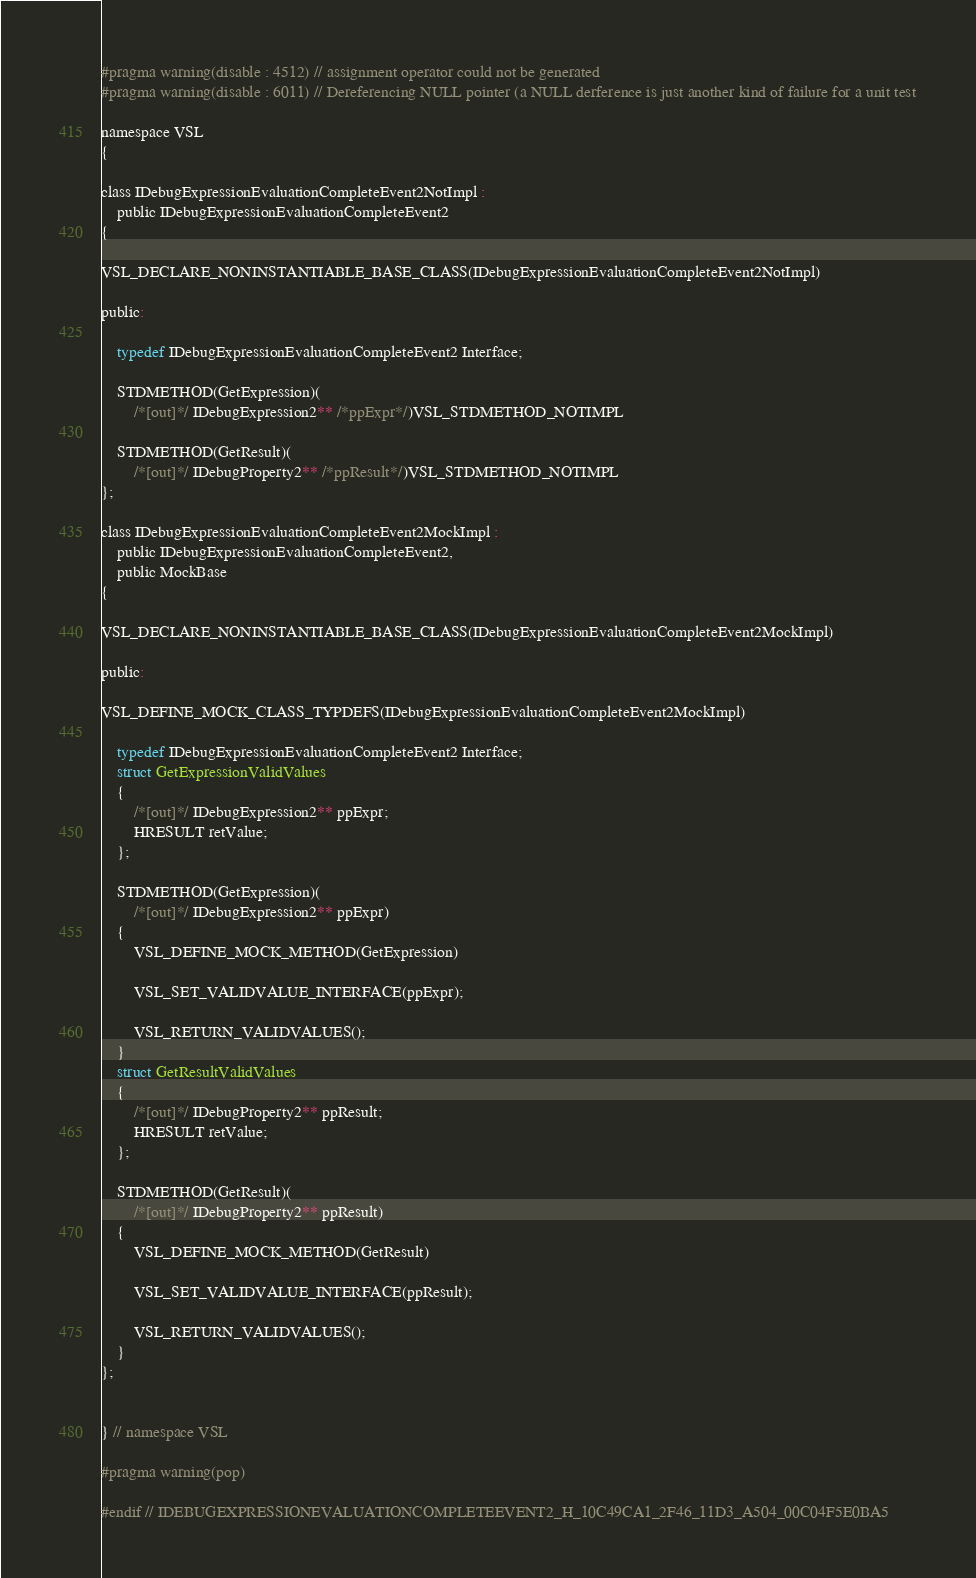<code> <loc_0><loc_0><loc_500><loc_500><_C_>#pragma warning(disable : 4512) // assignment operator could not be generated
#pragma warning(disable : 6011) // Dereferencing NULL pointer (a NULL derference is just another kind of failure for a unit test

namespace VSL
{

class IDebugExpressionEvaluationCompleteEvent2NotImpl :
	public IDebugExpressionEvaluationCompleteEvent2
{

VSL_DECLARE_NONINSTANTIABLE_BASE_CLASS(IDebugExpressionEvaluationCompleteEvent2NotImpl)

public:

	typedef IDebugExpressionEvaluationCompleteEvent2 Interface;

	STDMETHOD(GetExpression)(
		/*[out]*/ IDebugExpression2** /*ppExpr*/)VSL_STDMETHOD_NOTIMPL

	STDMETHOD(GetResult)(
		/*[out]*/ IDebugProperty2** /*ppResult*/)VSL_STDMETHOD_NOTIMPL
};

class IDebugExpressionEvaluationCompleteEvent2MockImpl :
	public IDebugExpressionEvaluationCompleteEvent2,
	public MockBase
{

VSL_DECLARE_NONINSTANTIABLE_BASE_CLASS(IDebugExpressionEvaluationCompleteEvent2MockImpl)

public:

VSL_DEFINE_MOCK_CLASS_TYPDEFS(IDebugExpressionEvaluationCompleteEvent2MockImpl)

	typedef IDebugExpressionEvaluationCompleteEvent2 Interface;
	struct GetExpressionValidValues
	{
		/*[out]*/ IDebugExpression2** ppExpr;
		HRESULT retValue;
	};

	STDMETHOD(GetExpression)(
		/*[out]*/ IDebugExpression2** ppExpr)
	{
		VSL_DEFINE_MOCK_METHOD(GetExpression)

		VSL_SET_VALIDVALUE_INTERFACE(ppExpr);

		VSL_RETURN_VALIDVALUES();
	}
	struct GetResultValidValues
	{
		/*[out]*/ IDebugProperty2** ppResult;
		HRESULT retValue;
	};

	STDMETHOD(GetResult)(
		/*[out]*/ IDebugProperty2** ppResult)
	{
		VSL_DEFINE_MOCK_METHOD(GetResult)

		VSL_SET_VALIDVALUE_INTERFACE(ppResult);

		VSL_RETURN_VALIDVALUES();
	}
};


} // namespace VSL

#pragma warning(pop)

#endif // IDEBUGEXPRESSIONEVALUATIONCOMPLETEEVENT2_H_10C49CA1_2F46_11D3_A504_00C04F5E0BA5
</code> 